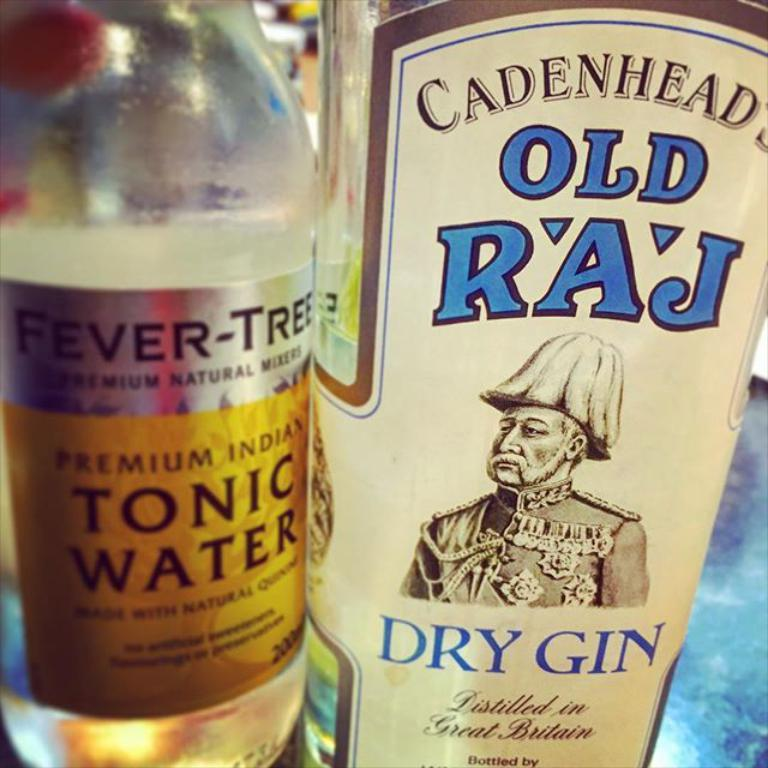How many bottles are visible in the image? There are two bottles in the image. What colors are the bottles? One bottle is cream-colored, and the other bottle is golden-colored. How are the bottles positioned in the image? The bottles are held side by side. What is the subject of the image? The image is of gin. Is there a blade visible in the image? No, there is no blade present in the image. Can you see a rabbit in the image? No, there is no rabbit present in the image. 